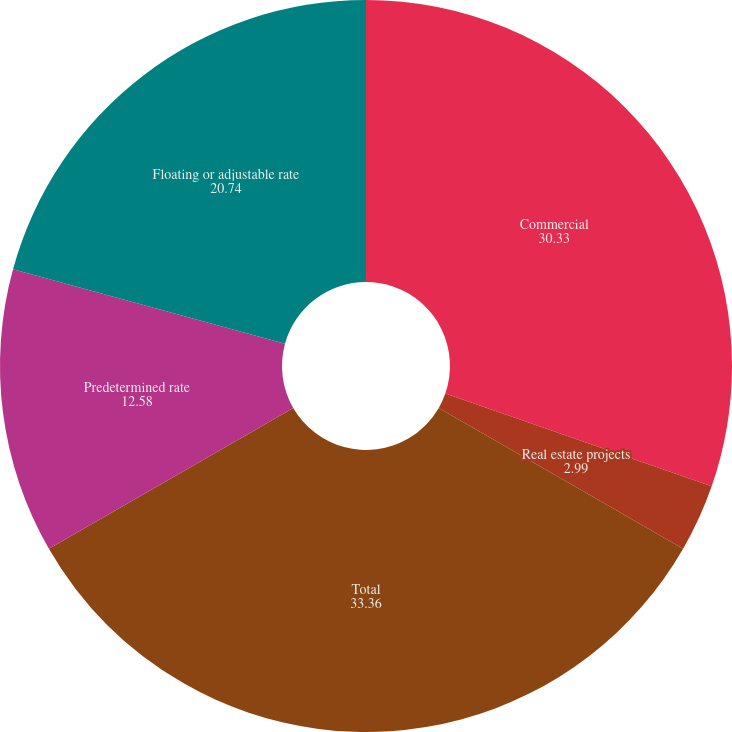Convert chart to OTSL. <chart><loc_0><loc_0><loc_500><loc_500><pie_chart><fcel>Commercial<fcel>Real estate projects<fcel>Total<fcel>Predetermined rate<fcel>Floating or adjustable rate<nl><fcel>30.33%<fcel>2.99%<fcel>33.36%<fcel>12.58%<fcel>20.74%<nl></chart> 